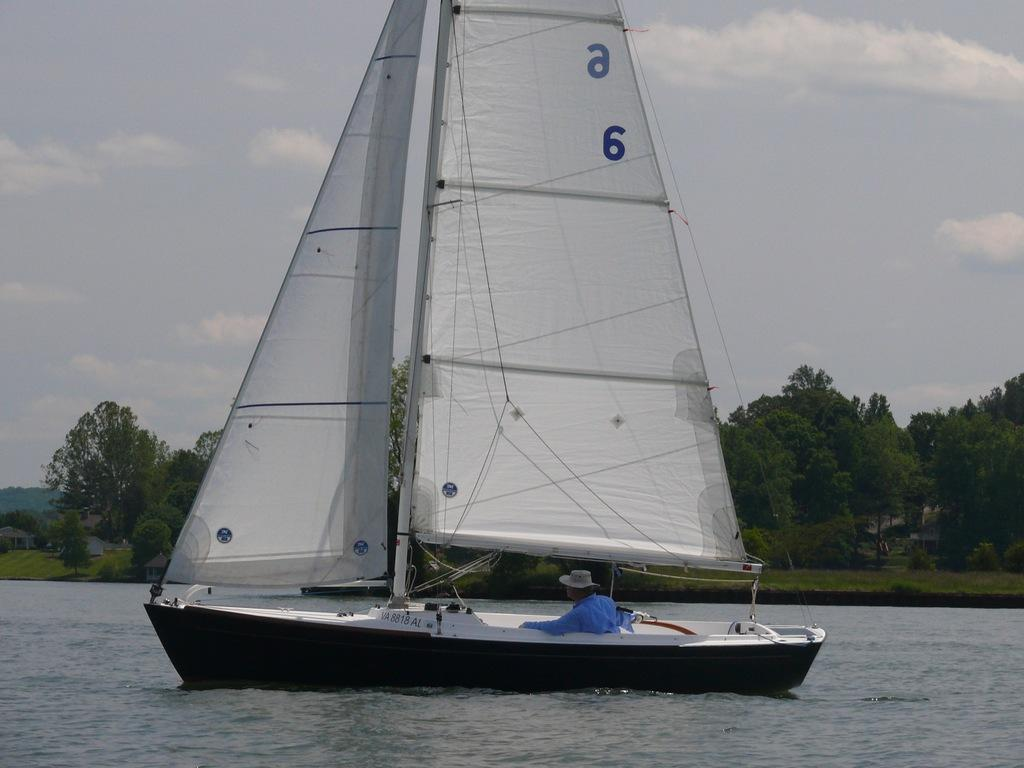Provide a one-sentence caption for the provided image. A small sailboat that says a6 on the sails has a man in a blue shirt steering it. 